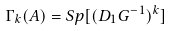Convert formula to latex. <formula><loc_0><loc_0><loc_500><loc_500>\Gamma _ { k } ( A ) = S p [ ( D _ { 1 } G ^ { - 1 } ) ^ { k } ]</formula> 